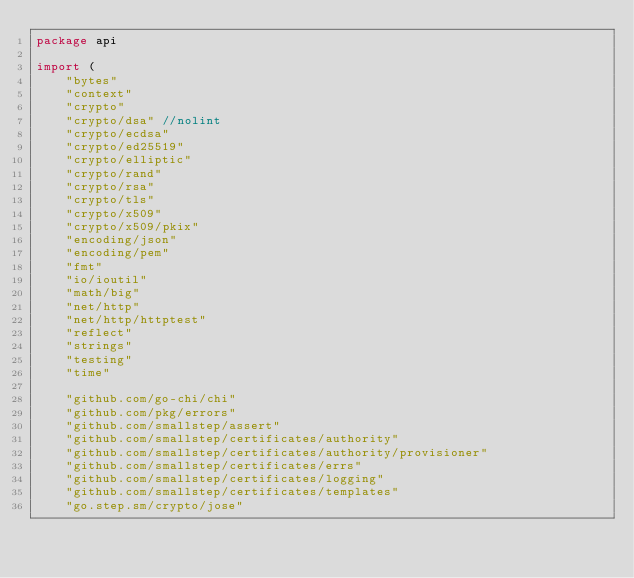Convert code to text. <code><loc_0><loc_0><loc_500><loc_500><_Go_>package api

import (
	"bytes"
	"context"
	"crypto"
	"crypto/dsa" //nolint
	"crypto/ecdsa"
	"crypto/ed25519"
	"crypto/elliptic"
	"crypto/rand"
	"crypto/rsa"
	"crypto/tls"
	"crypto/x509"
	"crypto/x509/pkix"
	"encoding/json"
	"encoding/pem"
	"fmt"
	"io/ioutil"
	"math/big"
	"net/http"
	"net/http/httptest"
	"reflect"
	"strings"
	"testing"
	"time"

	"github.com/go-chi/chi"
	"github.com/pkg/errors"
	"github.com/smallstep/assert"
	"github.com/smallstep/certificates/authority"
	"github.com/smallstep/certificates/authority/provisioner"
	"github.com/smallstep/certificates/errs"
	"github.com/smallstep/certificates/logging"
	"github.com/smallstep/certificates/templates"
	"go.step.sm/crypto/jose"</code> 